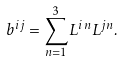Convert formula to latex. <formula><loc_0><loc_0><loc_500><loc_500>b ^ { i j } = \sum _ { n = 1 } ^ { 3 } L ^ { i n } L ^ { j n } .</formula> 